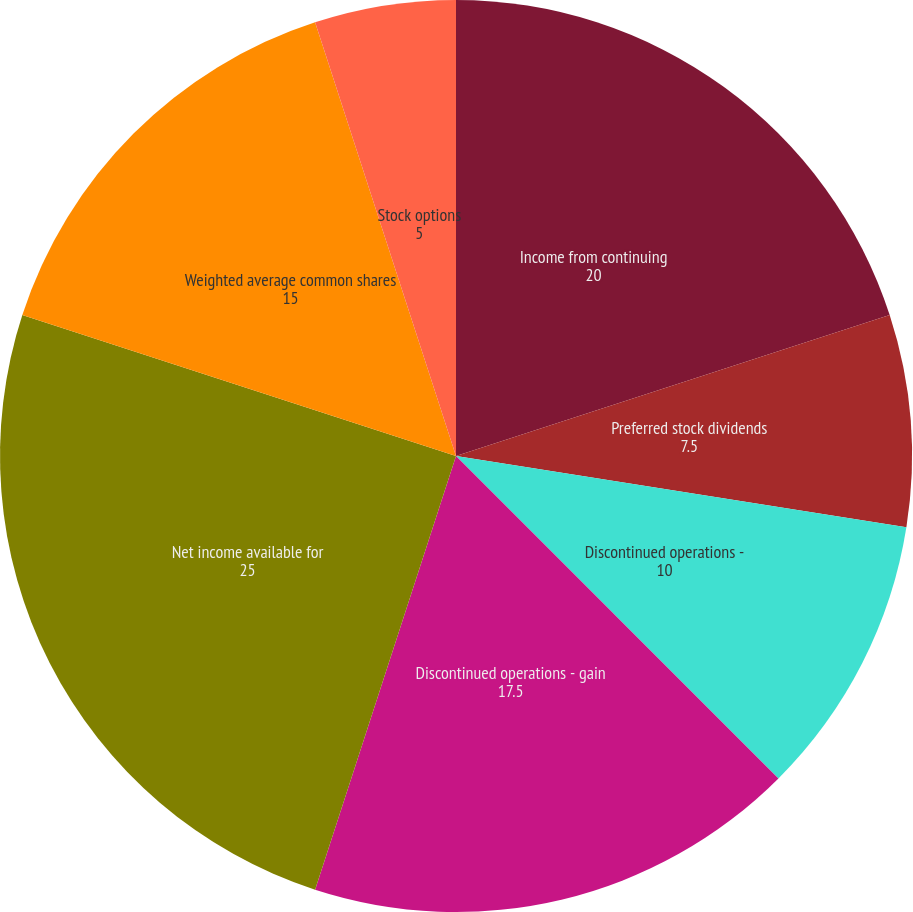Convert chart. <chart><loc_0><loc_0><loc_500><loc_500><pie_chart><fcel>Income from continuing<fcel>Preferred stock dividends<fcel>Discontinued operations -<fcel>Discontinued operations - gain<fcel>Net income available for<fcel>Weighted average common shares<fcel>Stock options<fcel>Continuing operations<nl><fcel>20.0%<fcel>7.5%<fcel>10.0%<fcel>17.5%<fcel>25.0%<fcel>15.0%<fcel>5.0%<fcel>0.0%<nl></chart> 